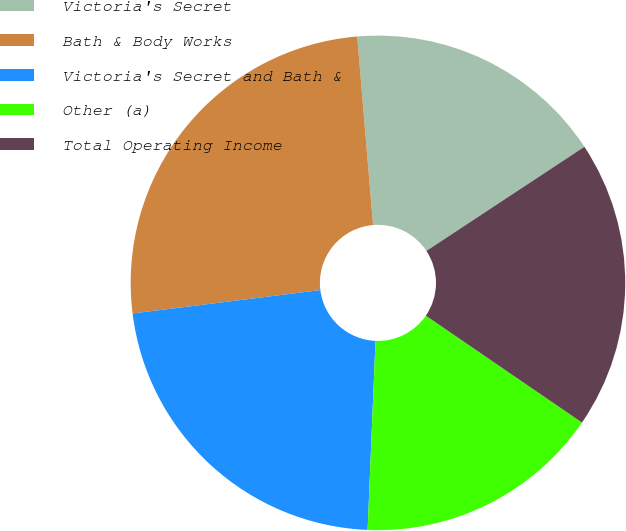Convert chart. <chart><loc_0><loc_0><loc_500><loc_500><pie_chart><fcel>Victoria's Secret<fcel>Bath & Body Works<fcel>Victoria's Secret and Bath &<fcel>Other (a)<fcel>Total Operating Income<nl><fcel>17.06%<fcel>25.64%<fcel>22.36%<fcel>16.11%<fcel>18.83%<nl></chart> 